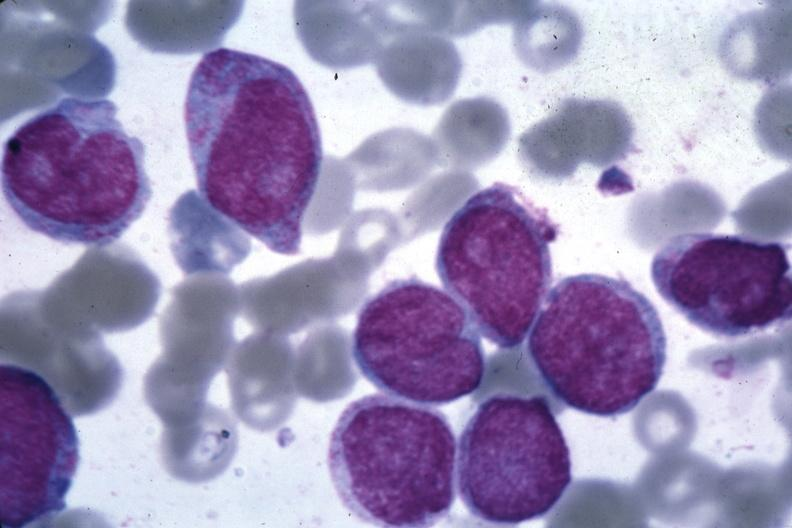what does this image show?
Answer the question using a single word or phrase. Oil wrights good photo blast cells 